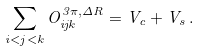<formula> <loc_0><loc_0><loc_500><loc_500>\sum _ { i < j < k } O ^ { 3 \pi , \Delta R } _ { i j k } = V _ { c } + V _ { s } \, .</formula> 